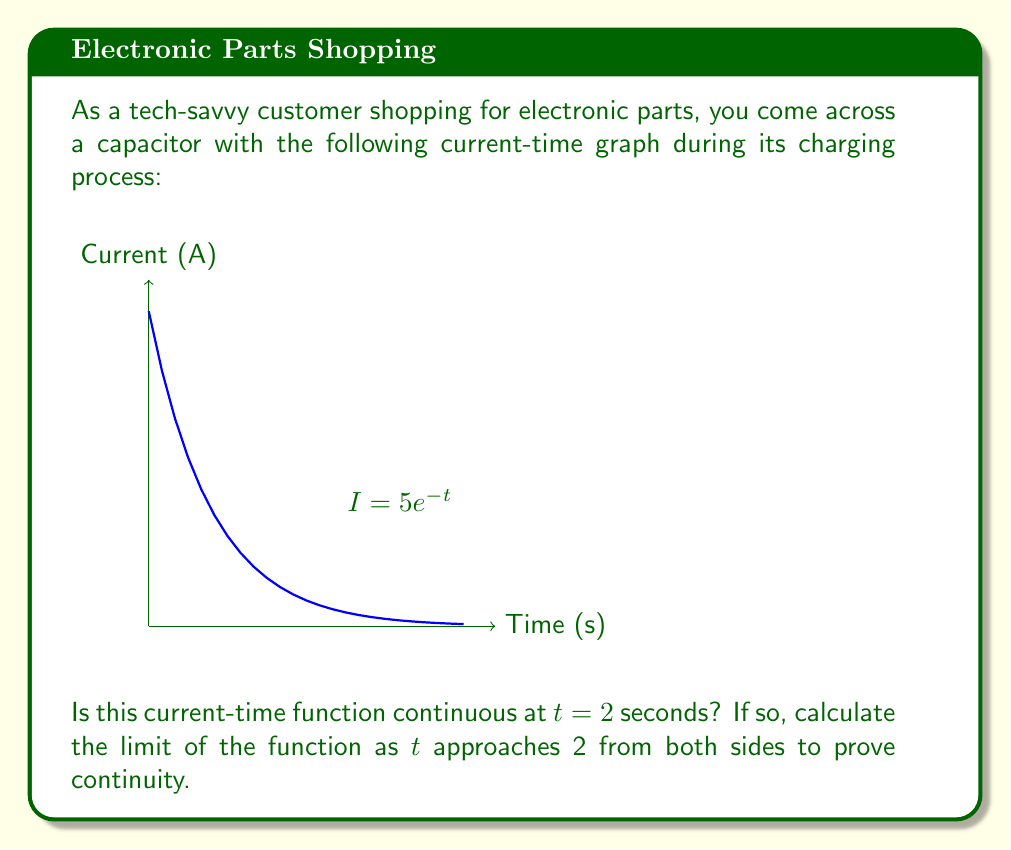Solve this math problem. To determine if the function is continuous at $t = 2$, we need to check three conditions:

1. The function $f(t)$ exists at $t = 2$
2. $\lim_{t \to 2^-} f(t)$ exists
3. $\lim_{t \to 2^+} f(t)$ exists
4. All three values are equal

Let's go through these steps:

1. The function exists at $t = 2$:
   $f(2) = 5e^{-2} \approx 0.6767$

2. Left-hand limit:
   $$\lim_{t \to 2^-} 5e^{-t} = 5e^{-2} \approx 0.6767$$

3. Right-hand limit:
   $$\lim_{t \to 2^+} 5e^{-t} = 5e^{-2} \approx 0.6767$$

4. Comparing the values:
   $f(2) = \lim_{t \to 2^-} f(t) = \lim_{t \to 2^+} f(t) = 5e^{-2}$

Since all three conditions are met and the values are equal, the function is continuous at $t = 2$.

The limit as $t$ approaches 2 from both sides is $5e^{-2}$, which proves the continuity of the function at this point.
Answer: Yes, continuous; $\lim_{t \to 2} 5e^{-t} = 5e^{-2}$ 